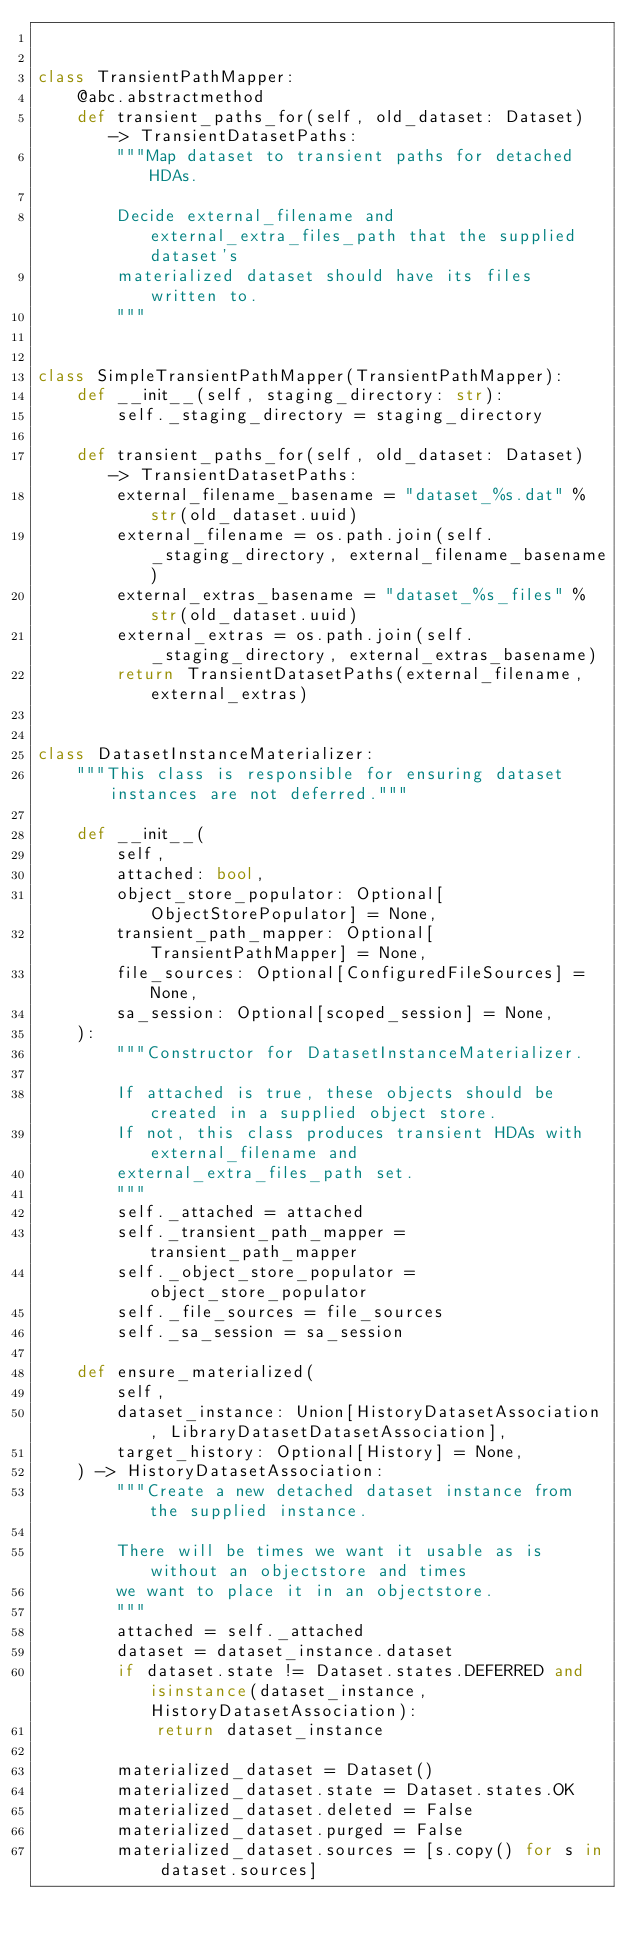Convert code to text. <code><loc_0><loc_0><loc_500><loc_500><_Python_>

class TransientPathMapper:
    @abc.abstractmethod
    def transient_paths_for(self, old_dataset: Dataset) -> TransientDatasetPaths:
        """Map dataset to transient paths for detached HDAs.

        Decide external_filename and external_extra_files_path that the supplied dataset's
        materialized dataset should have its files written to.
        """


class SimpleTransientPathMapper(TransientPathMapper):
    def __init__(self, staging_directory: str):
        self._staging_directory = staging_directory

    def transient_paths_for(self, old_dataset: Dataset) -> TransientDatasetPaths:
        external_filename_basename = "dataset_%s.dat" % str(old_dataset.uuid)
        external_filename = os.path.join(self._staging_directory, external_filename_basename)
        external_extras_basename = "dataset_%s_files" % str(old_dataset.uuid)
        external_extras = os.path.join(self._staging_directory, external_extras_basename)
        return TransientDatasetPaths(external_filename, external_extras)


class DatasetInstanceMaterializer:
    """This class is responsible for ensuring dataset instances are not deferred."""

    def __init__(
        self,
        attached: bool,
        object_store_populator: Optional[ObjectStorePopulator] = None,
        transient_path_mapper: Optional[TransientPathMapper] = None,
        file_sources: Optional[ConfiguredFileSources] = None,
        sa_session: Optional[scoped_session] = None,
    ):
        """Constructor for DatasetInstanceMaterializer.

        If attached is true, these objects should be created in a supplied object store.
        If not, this class produces transient HDAs with external_filename and
        external_extra_files_path set.
        """
        self._attached = attached
        self._transient_path_mapper = transient_path_mapper
        self._object_store_populator = object_store_populator
        self._file_sources = file_sources
        self._sa_session = sa_session

    def ensure_materialized(
        self,
        dataset_instance: Union[HistoryDatasetAssociation, LibraryDatasetDatasetAssociation],
        target_history: Optional[History] = None,
    ) -> HistoryDatasetAssociation:
        """Create a new detached dataset instance from the supplied instance.

        There will be times we want it usable as is without an objectstore and times
        we want to place it in an objectstore.
        """
        attached = self._attached
        dataset = dataset_instance.dataset
        if dataset.state != Dataset.states.DEFERRED and isinstance(dataset_instance, HistoryDatasetAssociation):
            return dataset_instance

        materialized_dataset = Dataset()
        materialized_dataset.state = Dataset.states.OK
        materialized_dataset.deleted = False
        materialized_dataset.purged = False
        materialized_dataset.sources = [s.copy() for s in dataset.sources]</code> 